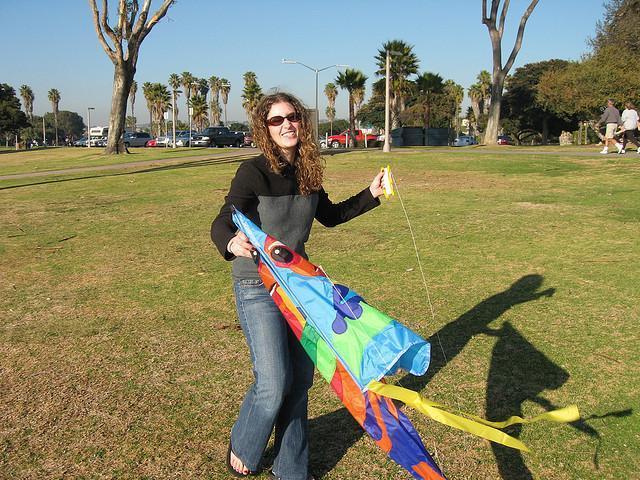How many red cars are in this picture?
Give a very brief answer. 2. How many sections does the donut have?
Give a very brief answer. 0. 